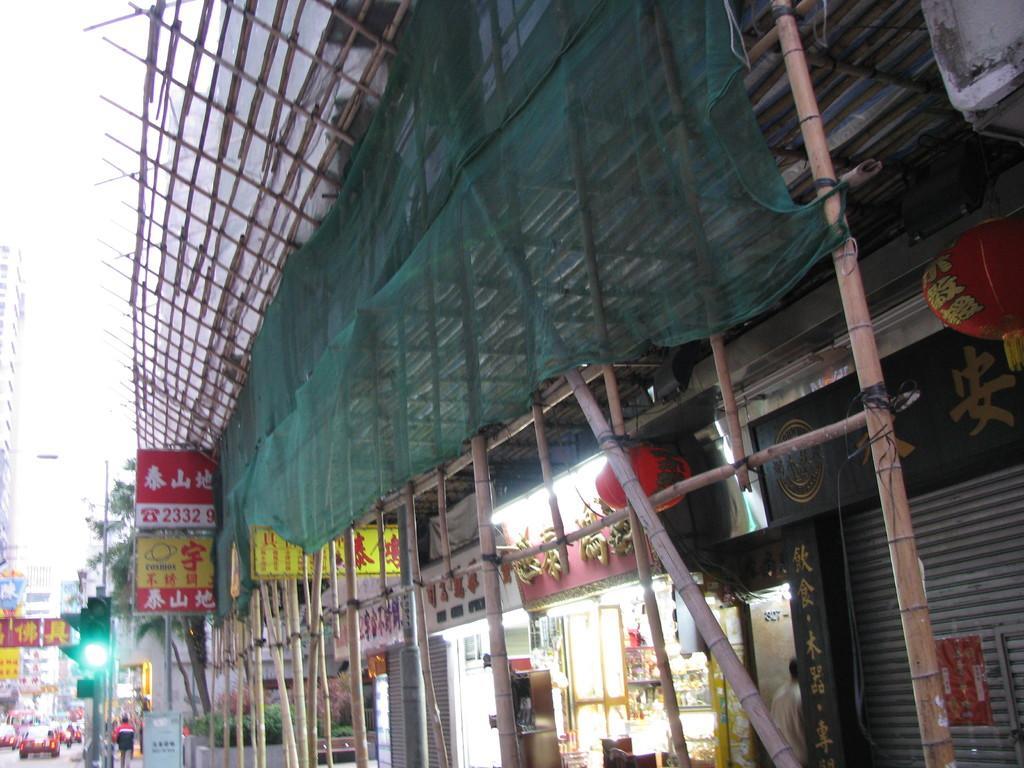In one or two sentences, can you explain what this image depicts? In this picture I can see vehicles on the road, there are buildings, boards, lights, paper lanterns, there are plants, trees, there are wooden poles and there is the sky. 